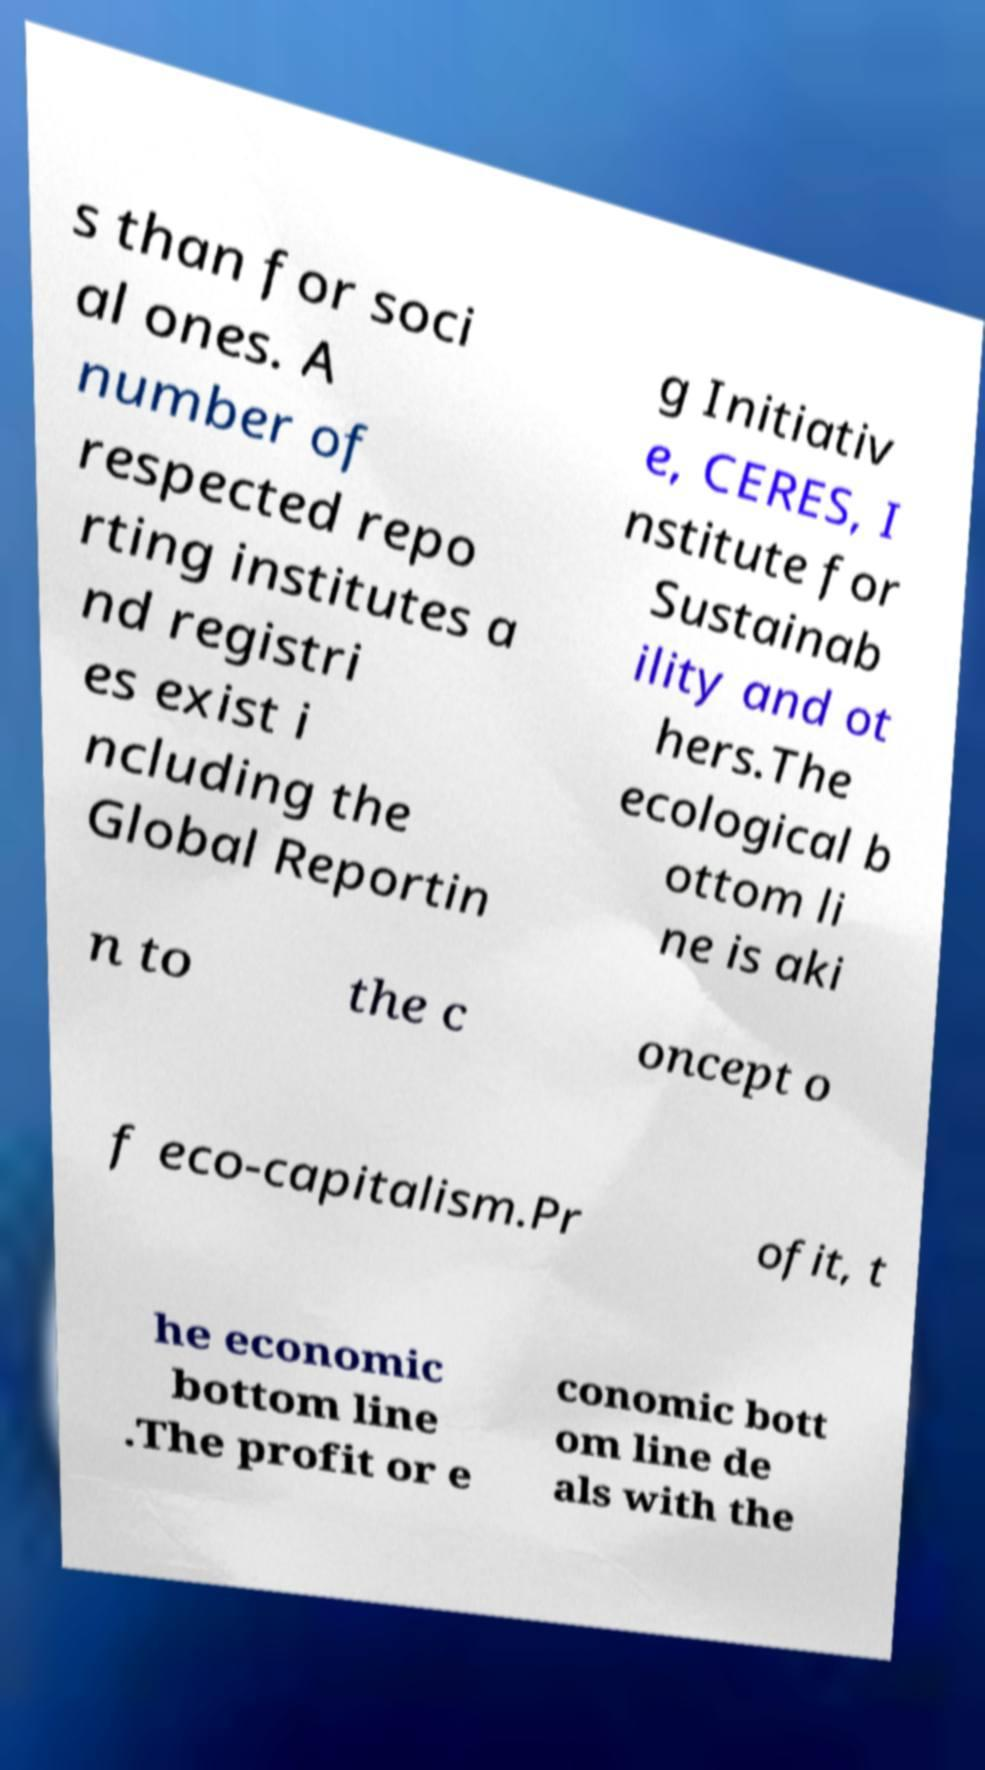I need the written content from this picture converted into text. Can you do that? s than for soci al ones. A number of respected repo rting institutes a nd registri es exist i ncluding the Global Reportin g Initiativ e, CERES, I nstitute for Sustainab ility and ot hers.The ecological b ottom li ne is aki n to the c oncept o f eco-capitalism.Pr ofit, t he economic bottom line .The profit or e conomic bott om line de als with the 